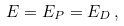Convert formula to latex. <formula><loc_0><loc_0><loc_500><loc_500>E = E _ { P } = E _ { D } \, ,</formula> 